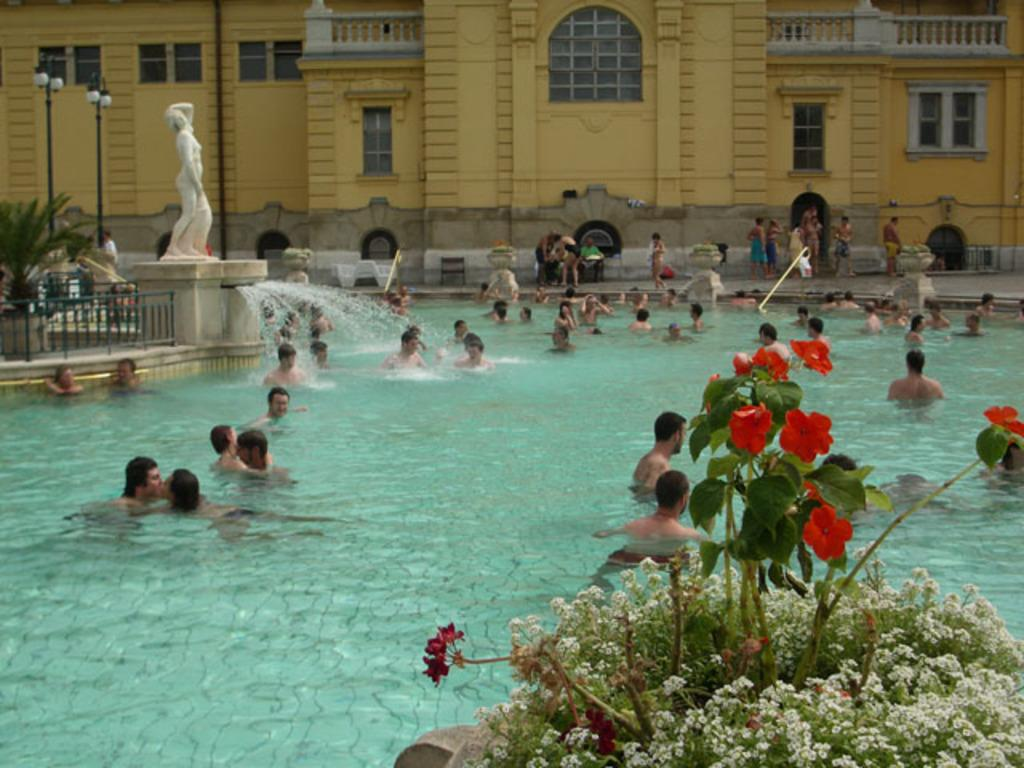What is the primary element visible in the image? There is water in the image. What types of vegetation can be seen in the image? There are plants and flowers in the image. Are there any human figures in the image? Yes, there are people in the image. What type of structure is present in the image? There is a statue in the image. What architectural feature can be seen in the image? There is a fence in the image. What type of lighting is present in the image? There are lights in the image. What type of man-made structures are visible in the image? There are buildings in the image. What part of the buildings can be seen in the image? There are windows in the image. What type of disease is affecting the plants in the image? There is no indication of any disease affecting the plants in the image. What type of silk can be seen draped over the statue in the image? There is no silk present in the image, and the statue is not draped with any fabric. 